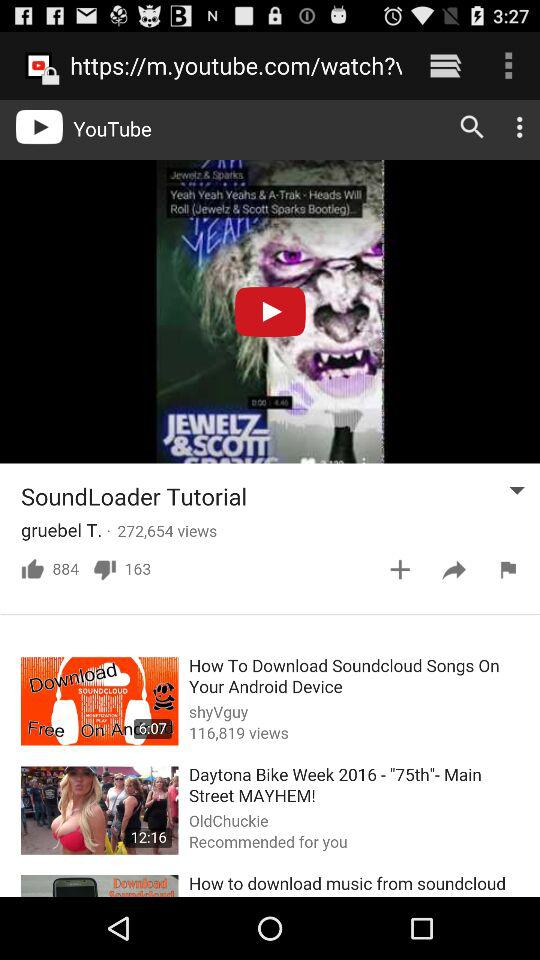What is the name of the video that has 116,819 views? The video that has 116,819 views is "How To Download Soundcloud Songs On Your Android Device". 